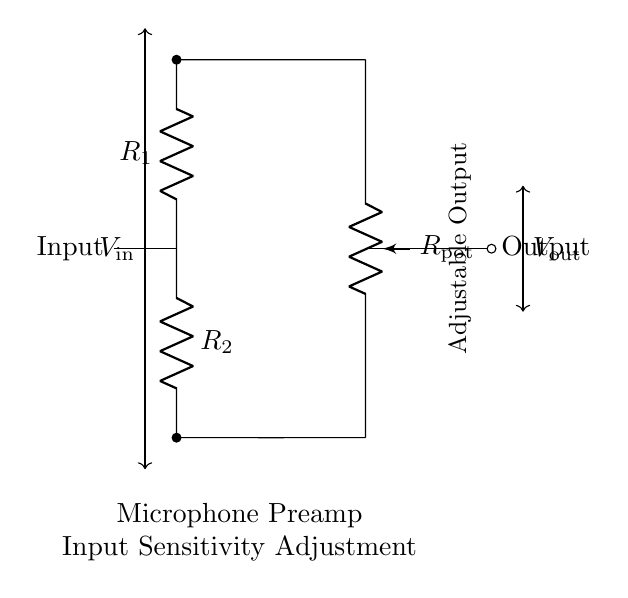What is the input component of this circuit? The input component is labeled as "Input" and connects to the resistor network formed by R1 and R2.
Answer: Input What does R1 represent in the circuit? R1 represents one of the resistors in the voltage divider configuration. It is connected in series with the input and the potentiometer.
Answer: R1 What type of circuit configuration is shown here? The configuration is a voltage divider, which is used to adjust the output voltage based on the ratio of the resistances.
Answer: Voltage Divider What is the purpose of the potentiometer in this circuit? The potentiometer allows for adjustable output voltage, enabling the user to fine-tune the sensitivity of the microphone preamp based on recording needs.
Answer: Adjustable Output How does the voltage output change if R1 is increased? If R1 is increased, the output voltage decreases since a larger part of the input voltage drops across R1, affecting the voltage divider ratio.
Answer: Decreases What is the relationship between R2 and output voltage? Increasing R2 would generally increase the output voltage since it affects the voltage division across R1 and R2, allowing more voltage to come through to the output.
Answer: Increases 